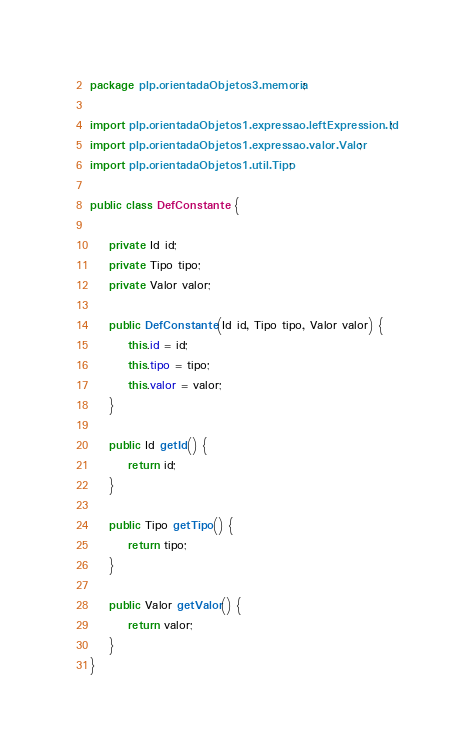<code> <loc_0><loc_0><loc_500><loc_500><_Java_>package plp.orientadaObjetos3.memoria;

import plp.orientadaObjetos1.expressao.leftExpression.Id;
import plp.orientadaObjetos1.expressao.valor.Valor;
import plp.orientadaObjetos1.util.Tipo;

public class DefConstante {

	private Id id;
	private Tipo tipo;
	private Valor valor;

	public DefConstante(Id id, Tipo tipo, Valor valor) {
		this.id = id;
		this.tipo = tipo;
		this.valor = valor;
	}
	
	public Id getId() {
		return id;
	}

	public Tipo getTipo() {
		return tipo;
	}

	public Valor getValor() {
		return valor;
	}
}
</code> 